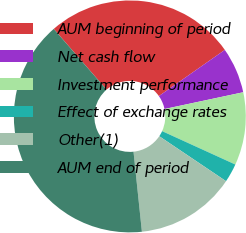<chart> <loc_0><loc_0><loc_500><loc_500><pie_chart><fcel>AUM beginning of period<fcel>Net cash flow<fcel>Investment performance<fcel>Effect of exchange rates<fcel>Other(1)<fcel>AUM end of period<nl><fcel>26.67%<fcel>6.38%<fcel>10.15%<fcel>2.62%<fcel>13.91%<fcel>40.27%<nl></chart> 